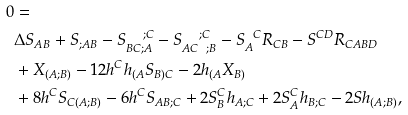<formula> <loc_0><loc_0><loc_500><loc_500>0 & = \\ & \Delta S _ { A B } + S _ { ; A B } - S _ { B C ; A } ^ { \quad ; C } - S _ { A C \ \ ; B } ^ { \quad ; C } - S _ { A } ^ { \ \ C } R _ { C B } - S ^ { C D } R _ { C A B D } \\ & + X _ { ( A ; B ) } - 1 2 h ^ { C } h _ { ( A } S _ { B ) C } - 2 h _ { ( A } X _ { B ) } \\ & + 8 h ^ { C } S _ { C ( A ; B ) } - 6 h ^ { C } S _ { A B ; C } + 2 S _ { B } ^ { C } h _ { A ; C } + 2 S _ { A } ^ { C } h _ { B ; C } - 2 S h _ { ( A ; B ) } ,</formula> 